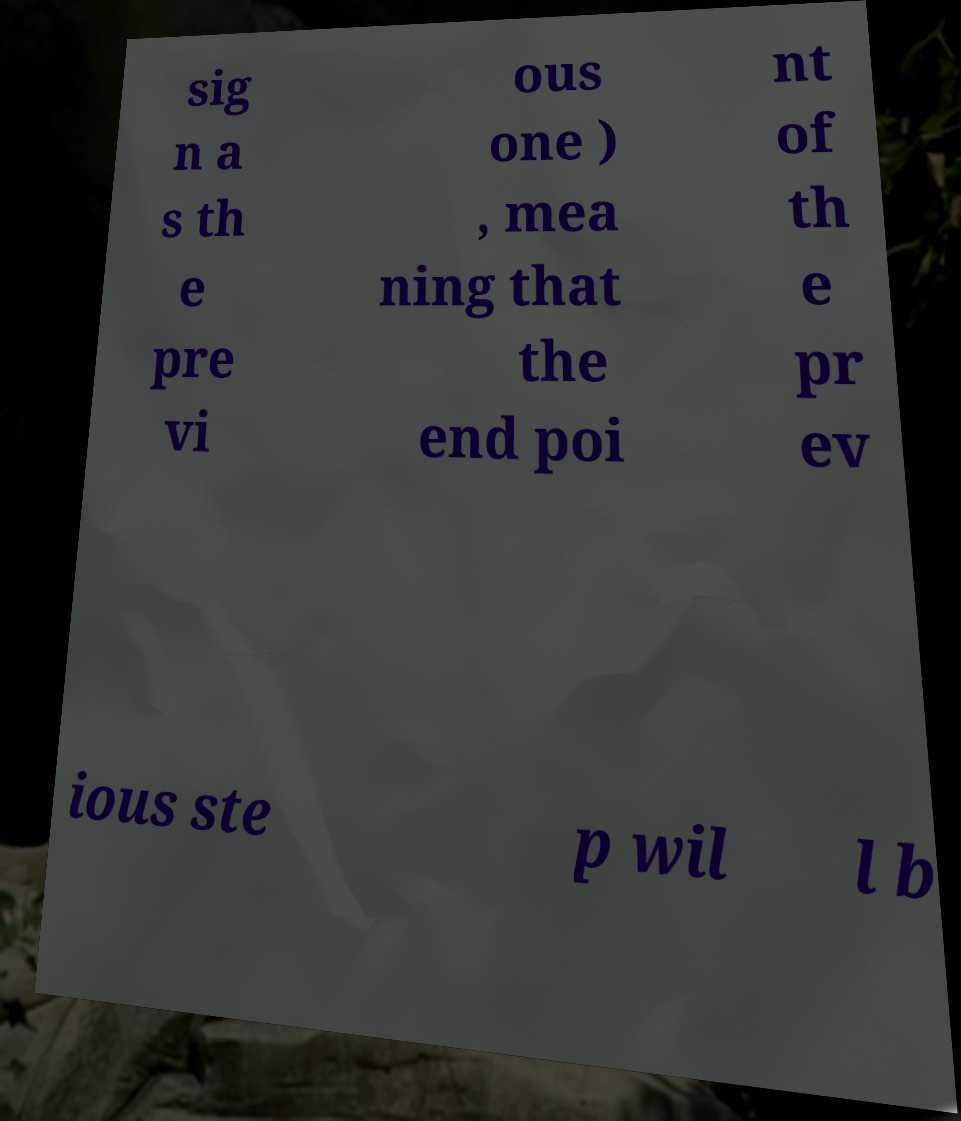Please identify and transcribe the text found in this image. sig n a s th e pre vi ous one ) , mea ning that the end poi nt of th e pr ev ious ste p wil l b 